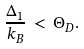<formula> <loc_0><loc_0><loc_500><loc_500>\frac { \Delta _ { 1 } } { k _ { B } } \, < \, \Theta _ { D } .</formula> 